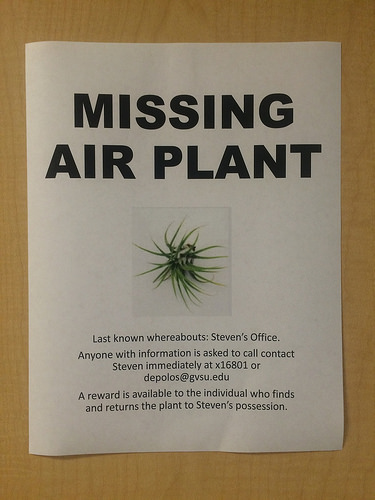<image>
Can you confirm if the plant is on the poster? Yes. Looking at the image, I can see the plant is positioned on top of the poster, with the poster providing support. 